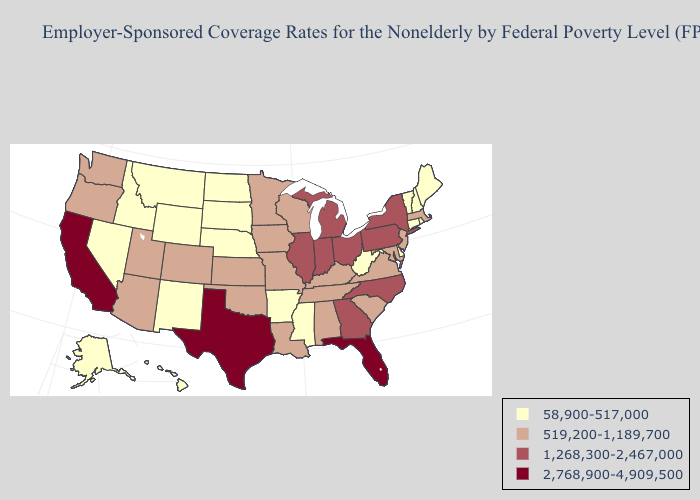Does New Jersey have the same value as Oklahoma?
Quick response, please. Yes. Does Louisiana have the lowest value in the South?
Answer briefly. No. What is the highest value in states that border Minnesota?
Be succinct. 519,200-1,189,700. Does Illinois have the highest value in the USA?
Answer briefly. No. What is the lowest value in states that border Michigan?
Give a very brief answer. 519,200-1,189,700. Name the states that have a value in the range 2,768,900-4,909,500?
Give a very brief answer. California, Florida, Texas. Which states have the lowest value in the USA?
Quick response, please. Alaska, Arkansas, Connecticut, Delaware, Hawaii, Idaho, Maine, Mississippi, Montana, Nebraska, Nevada, New Hampshire, New Mexico, North Dakota, Rhode Island, South Dakota, Vermont, West Virginia, Wyoming. What is the highest value in the MidWest ?
Concise answer only. 1,268,300-2,467,000. Name the states that have a value in the range 58,900-517,000?
Short answer required. Alaska, Arkansas, Connecticut, Delaware, Hawaii, Idaho, Maine, Mississippi, Montana, Nebraska, Nevada, New Hampshire, New Mexico, North Dakota, Rhode Island, South Dakota, Vermont, West Virginia, Wyoming. Is the legend a continuous bar?
Write a very short answer. No. Which states have the highest value in the USA?
Give a very brief answer. California, Florida, Texas. Does Missouri have the lowest value in the USA?
Give a very brief answer. No. Does Florida have the highest value in the USA?
Give a very brief answer. Yes. Which states have the highest value in the USA?
Give a very brief answer. California, Florida, Texas. What is the highest value in the USA?
Answer briefly. 2,768,900-4,909,500. 